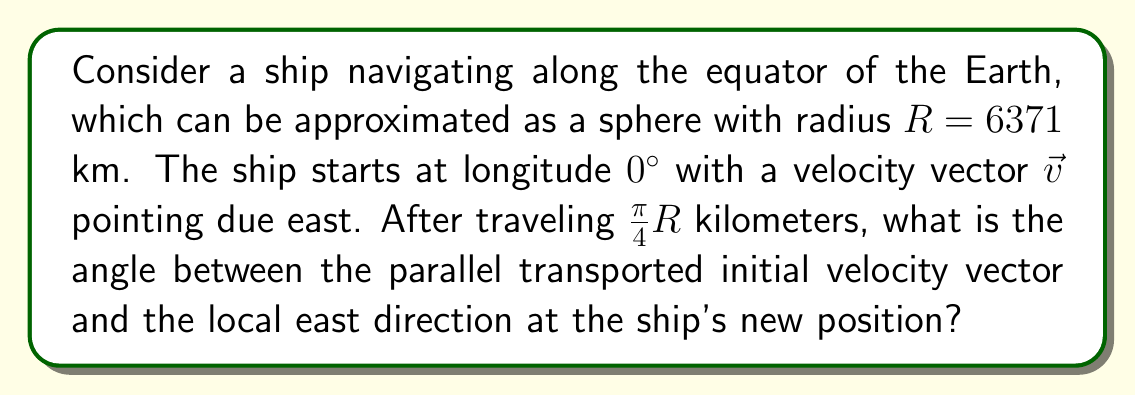Teach me how to tackle this problem. Let's approach this step-by-step:

1) First, we need to understand what parallel transport means on a sphere. When a vector is parallel transported along a great circle, it maintains a constant angle with the great circle.

2) The equator is a great circle on the Earth. The initial velocity vector $\vec{v}$ is tangent to the equator at the starting point.

3) As the ship moves along the equator, the parallel transported vector will remain tangent to the equator. However, the local east direction will change due to the curvature of the Earth.

4) The angle between the parallel transported vector and the local east direction at the new position will be equal to the angle of rotation of the Earth (i.e., the longitude difference).

5) To find this angle, we need to calculate how far the ship has traveled in terms of longitude:

   Distance traveled = $\frac{\pi}{4}R$
   
   Circumference of Earth = $2\pi R$

6) The fraction of the Earth's circumference traveled is:

   $\frac{\text{Distance traveled}}{\text{Circumference}} = \frac{\frac{\pi}{4}R}{2\pi R} = \frac{1}{8}$

7) Since a full circumference corresponds to 360°, the angle traveled is:

   $\theta = \frac{1}{8} \times 360° = 45°$

8) This 45° is the angle between the parallel transported initial velocity vector and the local east direction at the ship's new position.

[asy]
import geometry;

unitsize(1cm);

draw(circle((0,0),3));
draw((-3,0)--(3,0));
draw((0,-3)--(0,3));

label("0°", (-3.3,0), W);
label("45°", (2.3,2.3), NE);

draw((3,0)..(-2.12,2.12), blue, Arrow);
draw((-2.12,2.12)--(0,3), red, Arrow);

label("Parallel transported vector", (-1,2.5), N, blue);
label("Local east", (-1.5,3.2), N, red);

dot((3,0));
dot((-2.12,2.12));

label("Start", (3.3,0), E);
label("End", (-2.4,2.4), NW);
[/asy]
Answer: 45° 